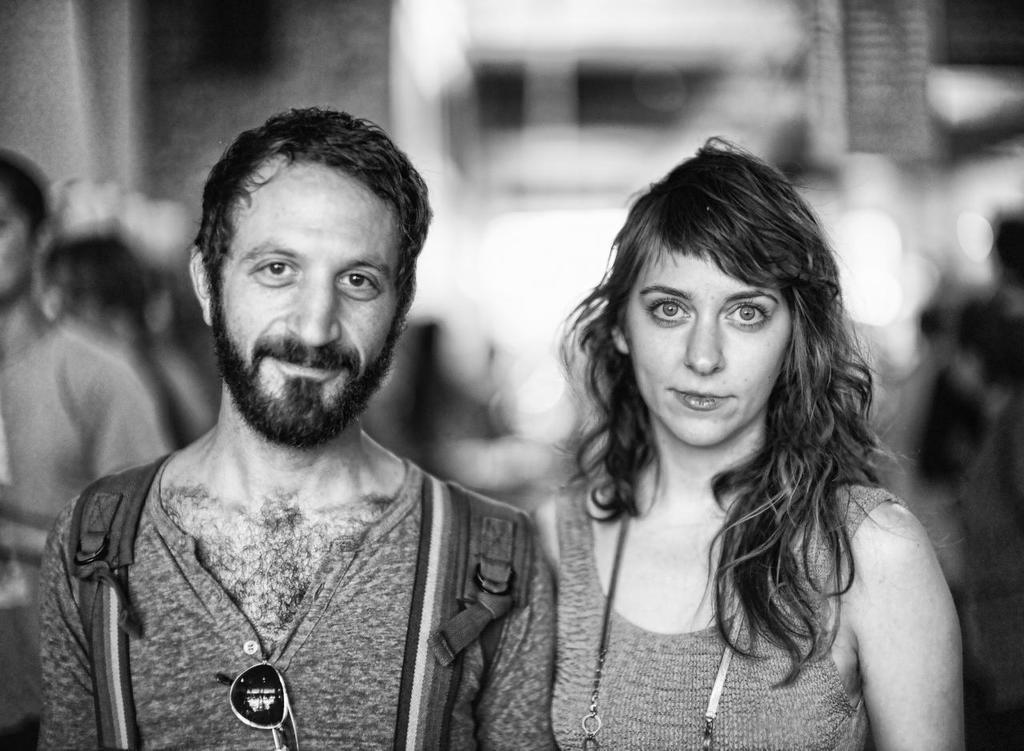Could you give a brief overview of what you see in this image? It is a black and white image there are two people standing in the foreground and posing for the photo and the background of them is blur. 